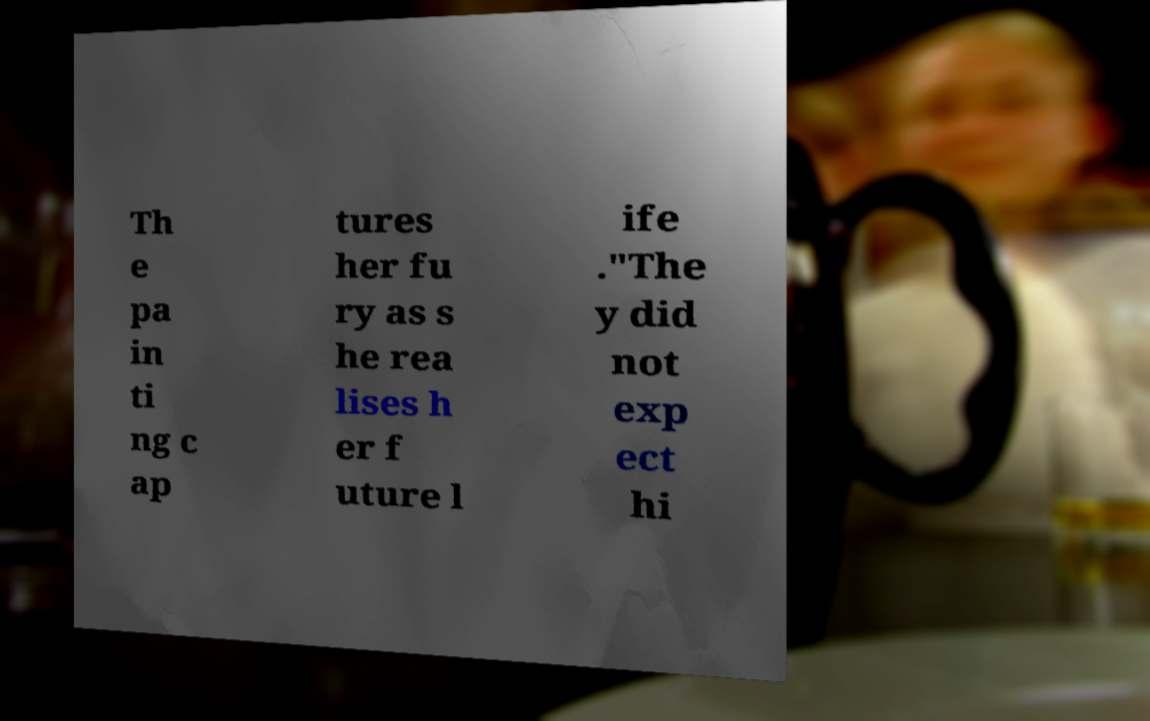Please read and relay the text visible in this image. What does it say? Th e pa in ti ng c ap tures her fu ry as s he rea lises h er f uture l ife ."The y did not exp ect hi 